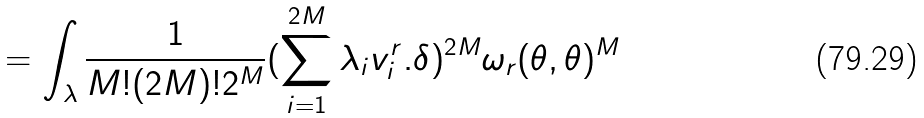<formula> <loc_0><loc_0><loc_500><loc_500>= \int _ { \lambda } \frac { 1 } { M ! ( 2 M ) ! 2 ^ { M } } ( \sum _ { i = 1 } ^ { 2 M } \lambda _ { i } v _ { i } ^ { r } . \delta ) ^ { 2 M } \omega _ { r } ( \theta , \theta ) ^ { M }</formula> 